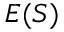<formula> <loc_0><loc_0><loc_500><loc_500>E ( S )</formula> 